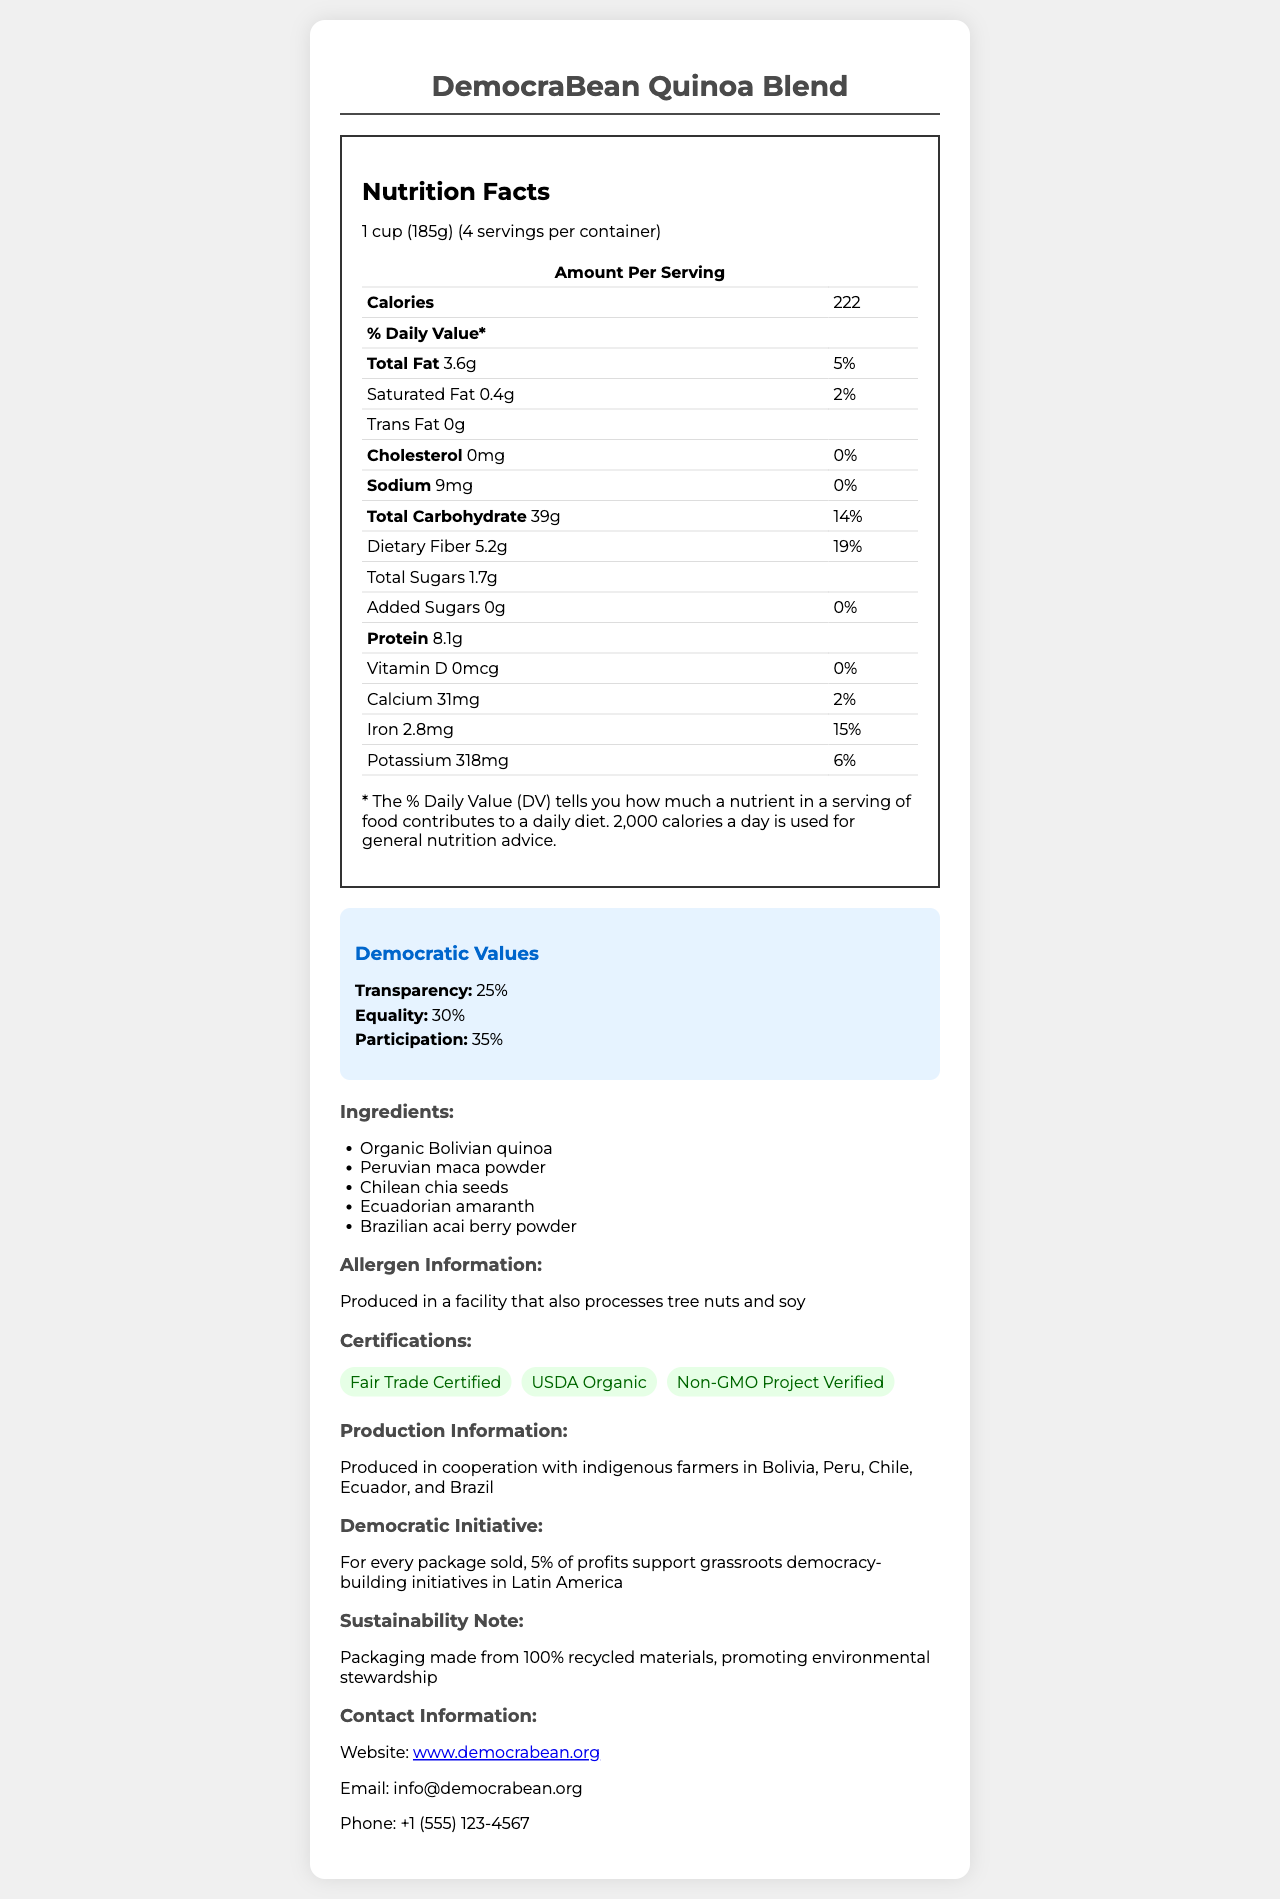what is the name of the product? The product name is listed at the beginning of the document as "DemocraBean Quinoa Blend".
Answer: DemocraBean Quinoa Blend how many servings are in one container? The document states that there are 4 servings per container.
Answer: 4 how many calories per serving? The document lists the calories per serving as 222.
Answer: 222 what is the total fat percentage of the daily value per serving? The document indicates that the total fat per serving is 3.6g, which is 5% of the daily value.
Answer: 5% what is the primary ingredient in the product? The first ingredient listed is "Organic Bolivian quinoa".
Answer: Organic Bolivian quinoa which ingredient is from Peru? A. Quinoa B. Maca powder C. Chia seeds D. Amaranth The ingredient from Peru is "Peruvian maca powder".
Answer: B. Maca powder what percentage of daily value does iron provide per serving? The table shows that the iron content per serving is 2.8mg, which is 15% of the daily value.
Answer: 15% are added sugars present in this product? The document shows that the added sugars amount is 0g with 0% daily value.
Answer: No does the product have certifications? The document lists several certifications: "Fair Trade Certified", "USDA Organic", "Non-GMO Project Verified".
Answer: Yes what is the sodium content per serving? A. 9mg B. 19mg C. 25mg D. 0mg The document lists the sodium content per serving as 9mg.
Answer: A. 9mg how much dietary fiber does one serving contain? The document indicates that one serving contains 5.2g of dietary fiber.
Answer: 5.2g does the product contain any trans fat? The document shows that the trans fat content is 0g.
Answer: No describe the democratic initiative associated with the product. The document explains that 5% of the profits from each package sold supports grassroots democracy-building initiatives in Latin America.
Answer: For every package sold, 5% of profits support grassroots democracy-building initiatives in Latin America are any vitamins like vitamin D or vitamin C present in the product? The document lists the amounts of vitamin D and vitamin C as 0mcg and 0mg respectively with 0% daily value.
Answer: No where is the DemocraBean Quinoa Blend produced? A. In a laboratory B. In cooperation with indigenous farmers in Latin America C. In a factory in the USA D. Cannot be determined The document states that the product is produced in cooperation with indigenous farmers in Bolivia, Peru, Chile, Ecuador, and Brazil.
Answer: B. In cooperation with indigenous farmers in Latin America what is the overall theme of the document? The document covers various aspects of the product such as its nutrition facts, democratic initiatives, ingredients sourced from different Latin American countries, certifications, allergen information, and sustainability notes.
Answer: The document provides detailed information about the nutrient content, ingredients, democratic values, and production details of the DemocraBean Quinoa Blend, a product promoting indigenous superfoods and democratic values in Latin America. what is the contact email address provided for the DemocraBean Quinoa Blend? The contact email address is listed as info@democrabean.org in the document.
Answer: info@democrabean.org what are the daily values of transparency and equality promoted by the product? The document lists the democratic values with daily values: Transparency 25% and Equality 30%.
Answer: 25% and 30% what percentage of daily value for protein does this product provide? The document only provides the amount of protein (8.1g) but does not specify the percentage of daily value for protein.
Answer: Cannot be determined 